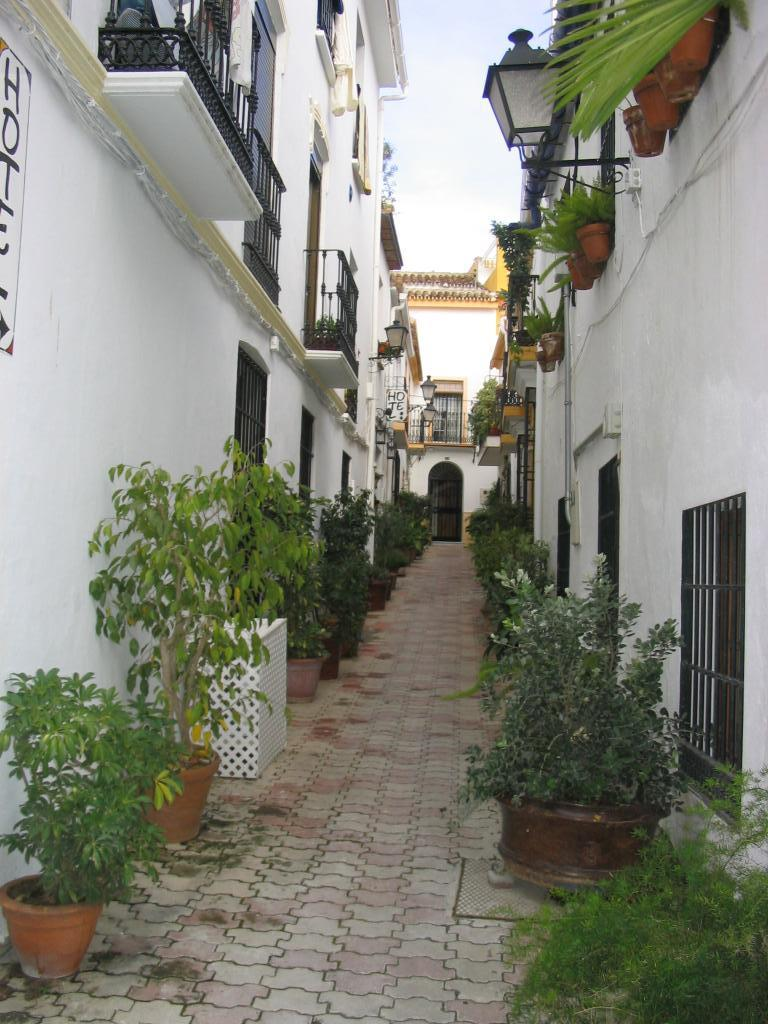What type of objects are present with the plants in the image? The plants are in pots in the image. What type of structures can be seen in the image? There are buildings in the image. What type of illumination is present in the image? There are lights in the image. What type of barriers are present in the image? There are fences in the image. What type of openings are present in the structures in the image? There are windows in the image. What can be seen in the background of the image? The sky is visible in the background of the image. What type of advertisement can be seen on the windows in the image? There is no advertisement present on the windows in the image. What day of the week is it in the image? The day of the week cannot be determined from the image. 